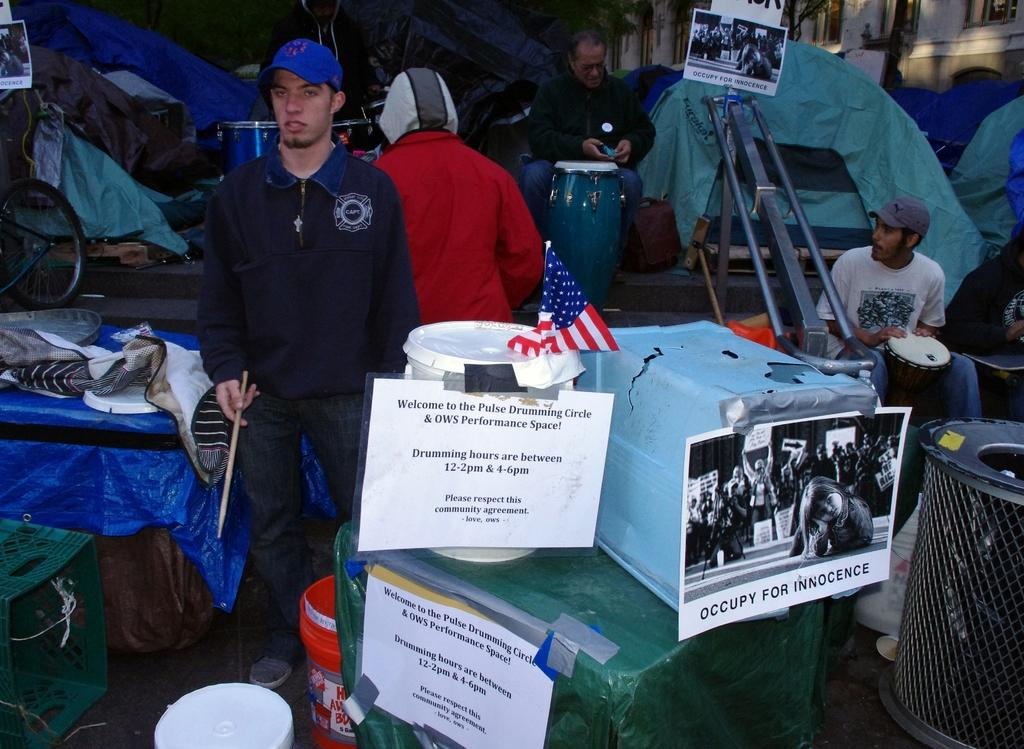How many people are present in the image? There are five people in the image, three standing and two seated. What are the seated people holding in their hands? Both seated people are holding drums in their hands. What type of disease is affecting the wing of the building in the image? There is no wing or building present in the image, and therefore no disease can be observed. 